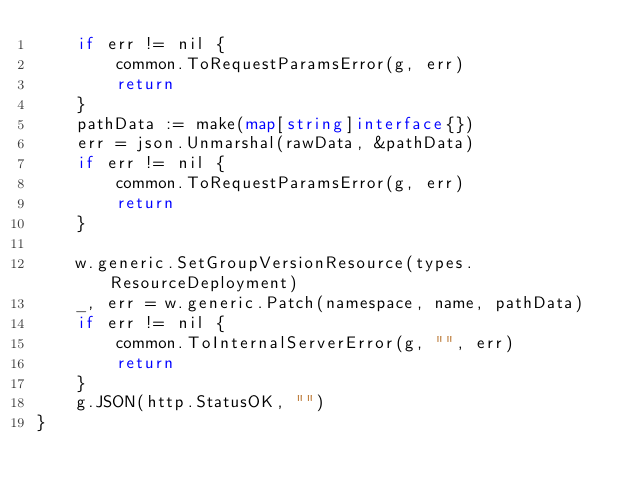Convert code to text. <code><loc_0><loc_0><loc_500><loc_500><_Go_>	if err != nil {
		common.ToRequestParamsError(g, err)
		return
	}
	pathData := make(map[string]interface{})
	err = json.Unmarshal(rawData, &pathData)
	if err != nil {
		common.ToRequestParamsError(g, err)
		return
	}

	w.generic.SetGroupVersionResource(types.ResourceDeployment)
	_, err = w.generic.Patch(namespace, name, pathData)
	if err != nil {
		common.ToInternalServerError(g, "", err)
		return
	}
	g.JSON(http.StatusOK, "")
}
</code> 